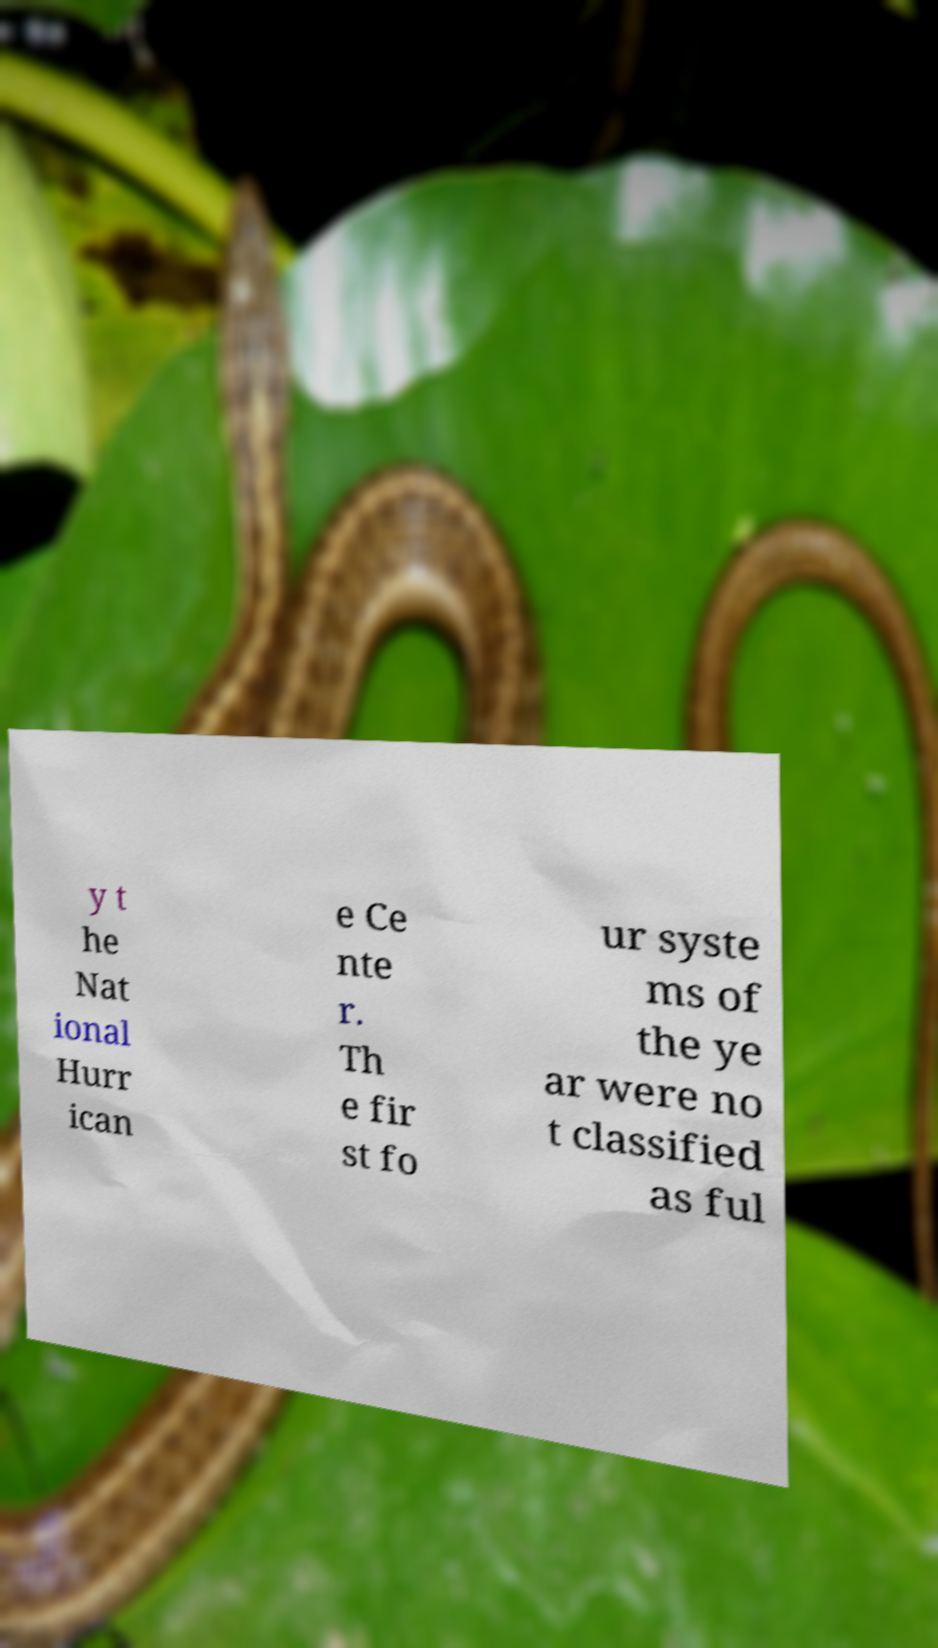Please identify and transcribe the text found in this image. y t he Nat ional Hurr ican e Ce nte r. Th e fir st fo ur syste ms of the ye ar were no t classified as ful 